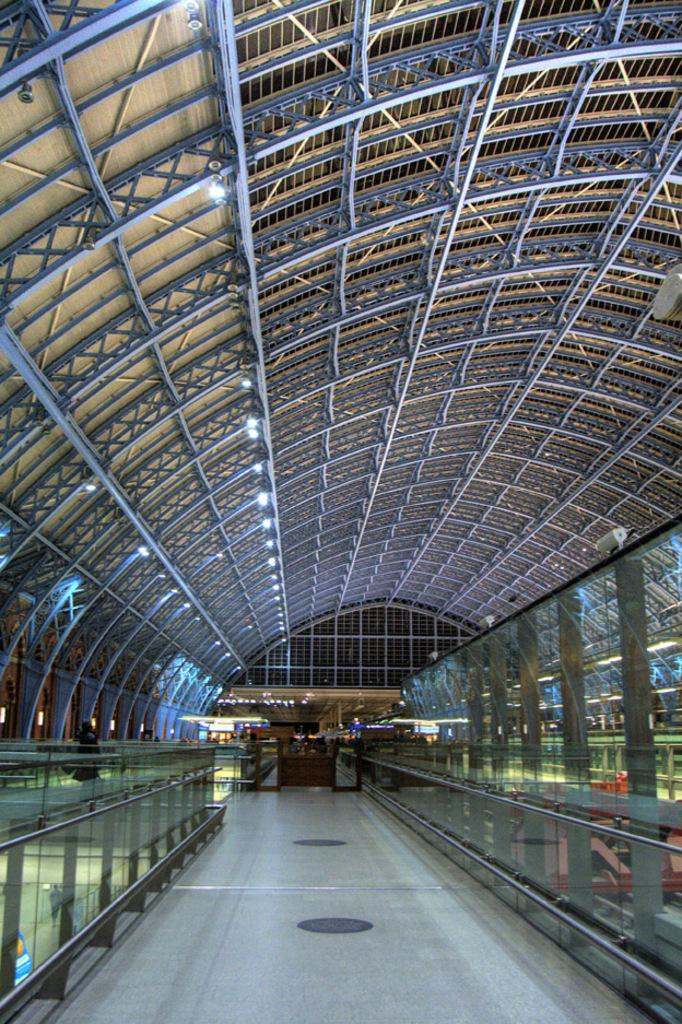What can be seen running through the image? There is a path in the image. What type of barrier is present along the path? There is a glass fence on the path. What else can be found on the path? There are other items on the path. What type of lighting is visible in the image? There are ceiling lights visible in the image. What type of cord is being used for war in the image? There is no mention of a cord or war in the image; it features a path with a glass fence and other items. 